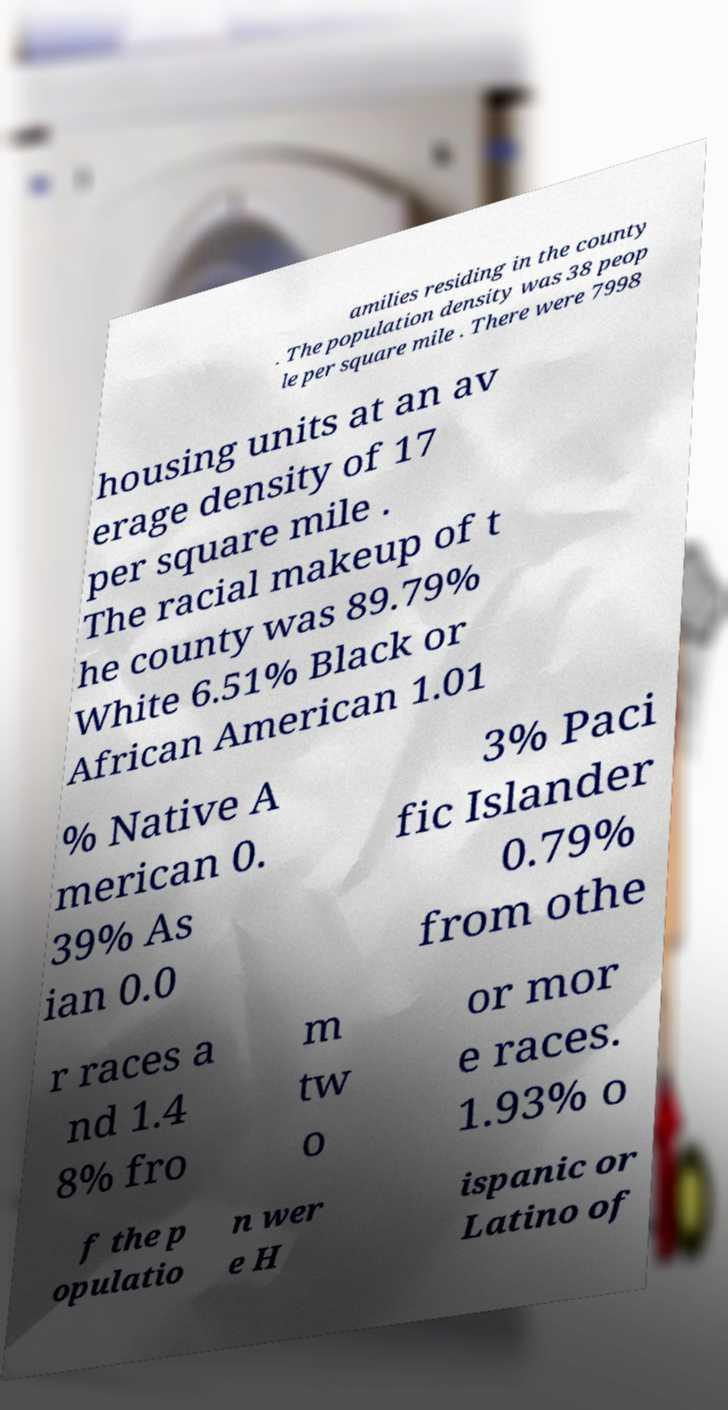I need the written content from this picture converted into text. Can you do that? amilies residing in the county . The population density was 38 peop le per square mile . There were 7998 housing units at an av erage density of 17 per square mile . The racial makeup of t he county was 89.79% White 6.51% Black or African American 1.01 % Native A merican 0. 39% As ian 0.0 3% Paci fic Islander 0.79% from othe r races a nd 1.4 8% fro m tw o or mor e races. 1.93% o f the p opulatio n wer e H ispanic or Latino of 